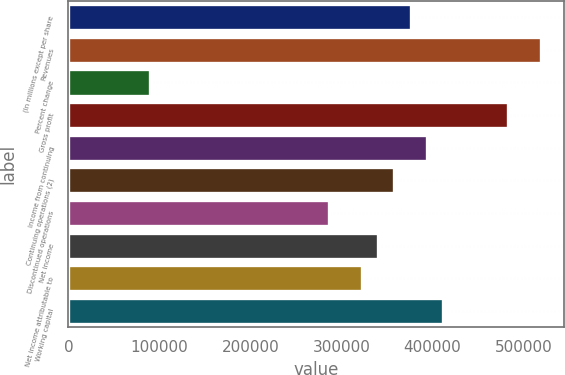Convert chart to OTSL. <chart><loc_0><loc_0><loc_500><loc_500><bar_chart><fcel>(In millions except per share<fcel>Revenues<fcel>Percent change<fcel>Gross profit<fcel>Income from continuing<fcel>Continuing operations (2)<fcel>Discontinued operations<fcel>Net income<fcel>Net income attributable to<fcel>Working capital<nl><fcel>375993<fcel>519229<fcel>89523<fcel>483420<fcel>393898<fcel>358089<fcel>286471<fcel>340185<fcel>322280<fcel>411802<nl></chart> 